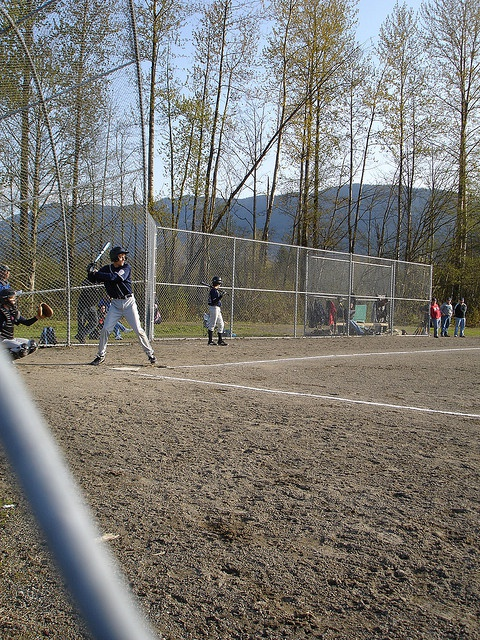Describe the objects in this image and their specific colors. I can see people in gray, black, and white tones, people in gray, black, darkgray, and lightgray tones, people in gray, black, darkgray, and darkgreen tones, people in gray, black, white, and darkgray tones, and people in gray, black, navy, and blue tones in this image. 